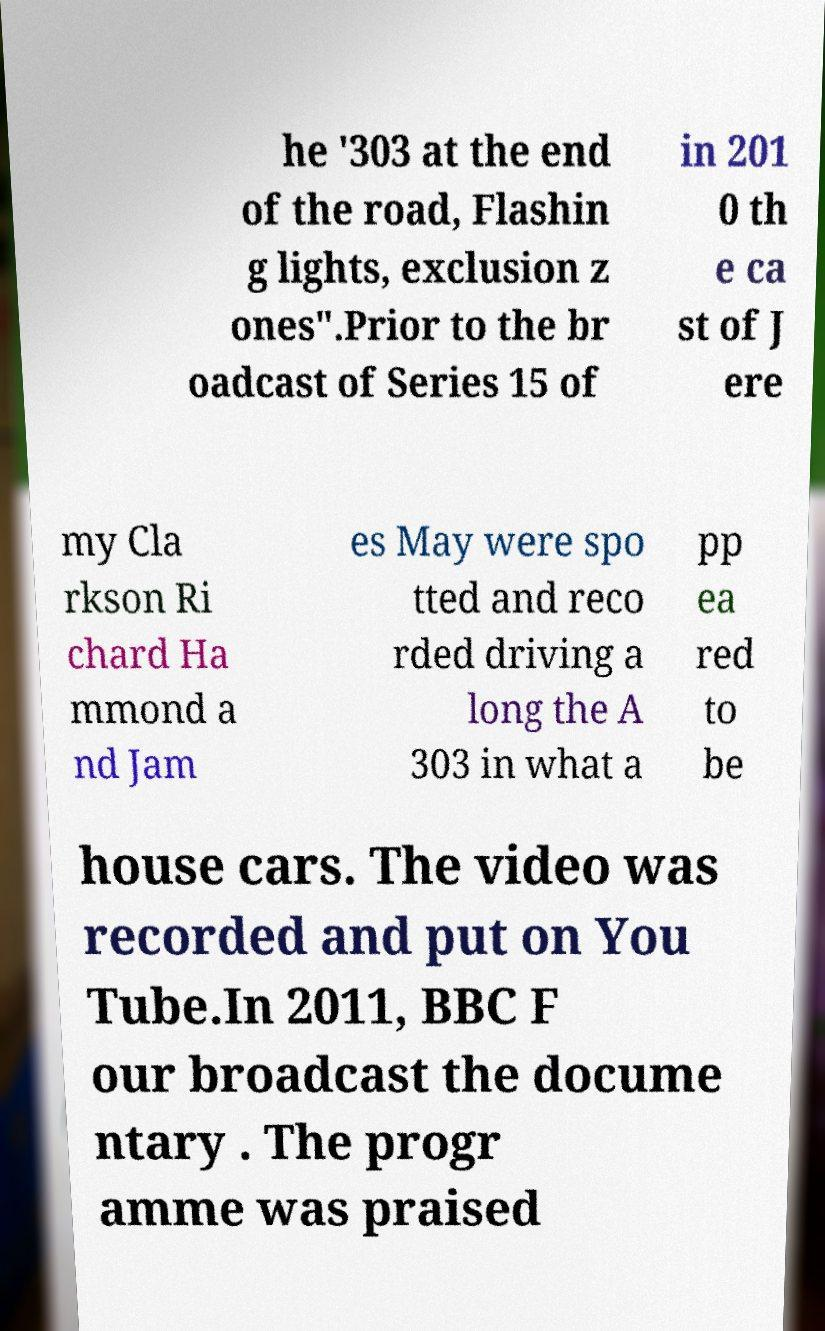Could you assist in decoding the text presented in this image and type it out clearly? he '303 at the end of the road, Flashin g lights, exclusion z ones".Prior to the br oadcast of Series 15 of in 201 0 th e ca st of J ere my Cla rkson Ri chard Ha mmond a nd Jam es May were spo tted and reco rded driving a long the A 303 in what a pp ea red to be house cars. The video was recorded and put on You Tube.In 2011, BBC F our broadcast the docume ntary . The progr amme was praised 